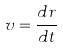Convert formula to latex. <formula><loc_0><loc_0><loc_500><loc_500>v = \frac { d r } { d t }</formula> 